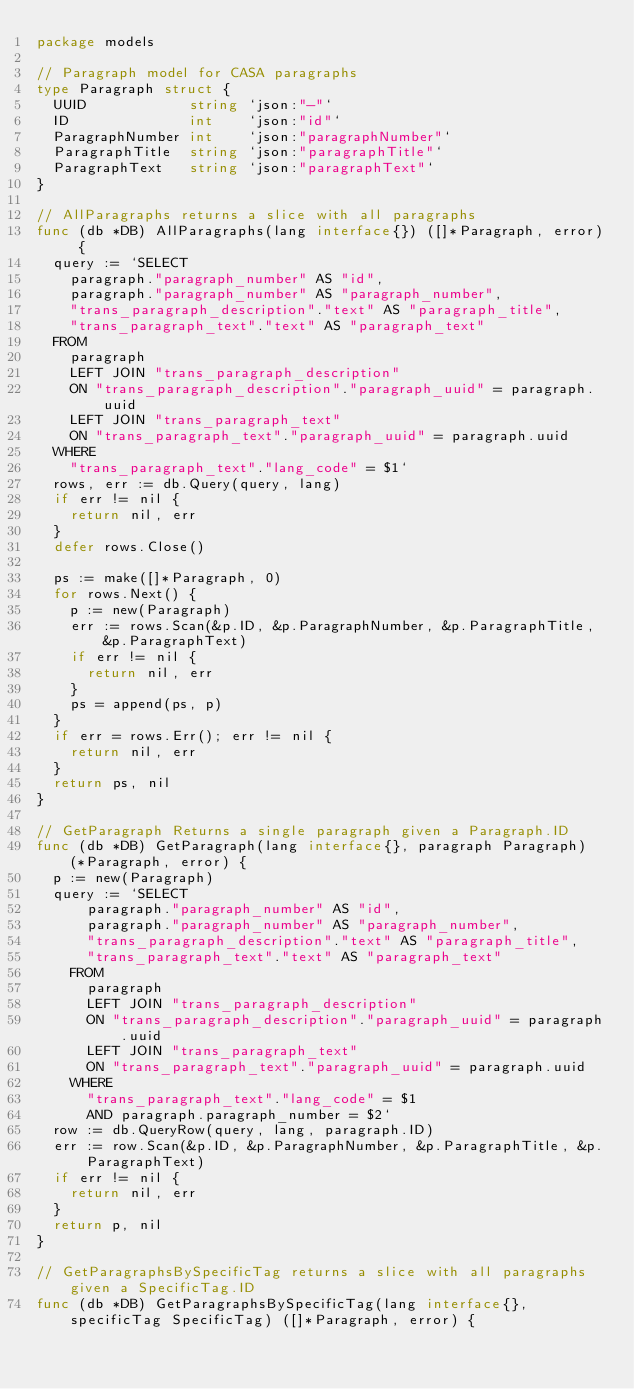<code> <loc_0><loc_0><loc_500><loc_500><_Go_>package models

// Paragraph model for CASA paragraphs
type Paragraph struct {
	UUID            string `json:"-"`
	ID              int    `json:"id"`
	ParagraphNumber int    `json:"paragraphNumber"`
	ParagraphTitle  string `json:"paragraphTitle"`
	ParagraphText   string `json:"paragraphText"`
}

// AllParagraphs returns a slice with all paragraphs
func (db *DB) AllParagraphs(lang interface{}) ([]*Paragraph, error) {
	query := `SELECT
		paragraph."paragraph_number" AS "id",
		paragraph."paragraph_number" AS "paragraph_number",
		"trans_paragraph_description"."text" AS "paragraph_title",
		"trans_paragraph_text"."text" AS "paragraph_text"
	FROM
		paragraph
		LEFT JOIN "trans_paragraph_description"
		ON "trans_paragraph_description"."paragraph_uuid" = paragraph.uuid 
		LEFT JOIN "trans_paragraph_text"
		ON "trans_paragraph_text"."paragraph_uuid" = paragraph.uuid 
	WHERE
		"trans_paragraph_text"."lang_code" = $1`
	rows, err := db.Query(query, lang)
	if err != nil {
		return nil, err
	}
	defer rows.Close()

	ps := make([]*Paragraph, 0)
	for rows.Next() {
		p := new(Paragraph)
		err := rows.Scan(&p.ID, &p.ParagraphNumber, &p.ParagraphTitle, &p.ParagraphText)
		if err != nil {
			return nil, err
		}
		ps = append(ps, p)
	}
	if err = rows.Err(); err != nil {
		return nil, err
	}
	return ps, nil
}

// GetParagraph Returns a single paragraph given a Paragraph.ID
func (db *DB) GetParagraph(lang interface{}, paragraph Paragraph) (*Paragraph, error) {
	p := new(Paragraph)
	query := `SELECT
			paragraph."paragraph_number" AS "id",
			paragraph."paragraph_number" AS "paragraph_number",
			"trans_paragraph_description"."text" AS "paragraph_title",
			"trans_paragraph_text"."text" AS "paragraph_text"
		FROM
			paragraph
			LEFT JOIN "trans_paragraph_description"
			ON "trans_paragraph_description"."paragraph_uuid" = paragraph.uuid 
			LEFT JOIN "trans_paragraph_text"
			ON "trans_paragraph_text"."paragraph_uuid" = paragraph.uuid 
		WHERE
			"trans_paragraph_text"."lang_code" = $1
			AND paragraph.paragraph_number = $2`
	row := db.QueryRow(query, lang, paragraph.ID)
	err := row.Scan(&p.ID, &p.ParagraphNumber, &p.ParagraphTitle, &p.ParagraphText)
	if err != nil {
		return nil, err
	}
	return p, nil
}

// GetParagraphsBySpecificTag returns a slice with all paragraphs given a SpecificTag.ID
func (db *DB) GetParagraphsBySpecificTag(lang interface{}, specificTag SpecificTag) ([]*Paragraph, error) {</code> 